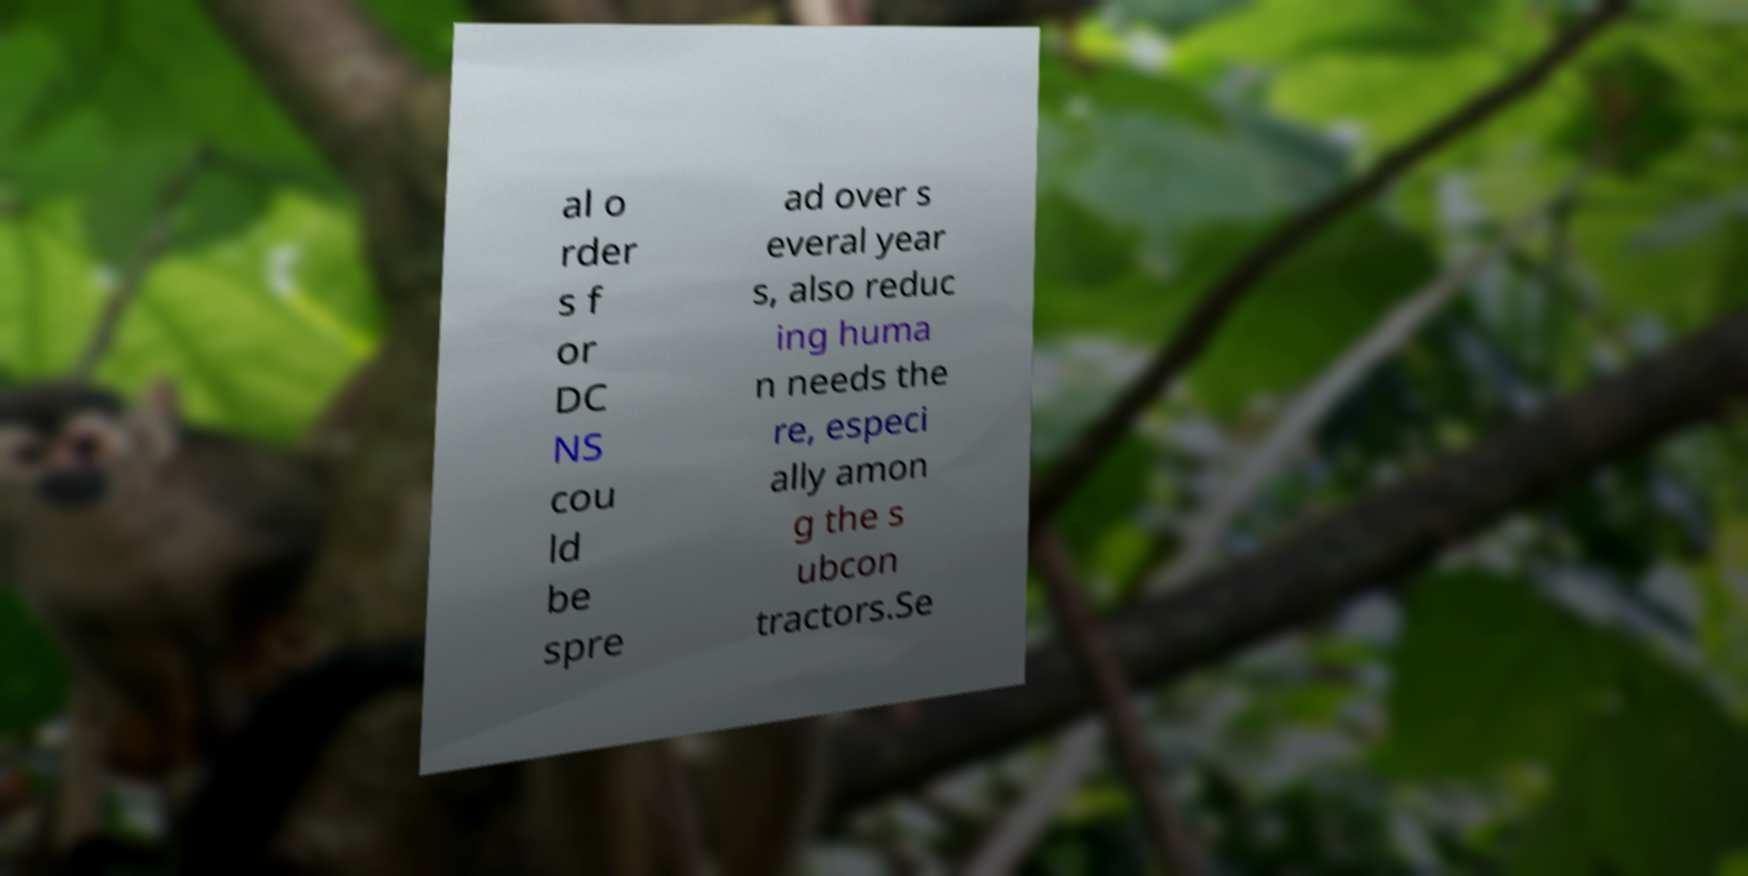Can you accurately transcribe the text from the provided image for me? al o rder s f or DC NS cou ld be spre ad over s everal year s, also reduc ing huma n needs the re, especi ally amon g the s ubcon tractors.Se 